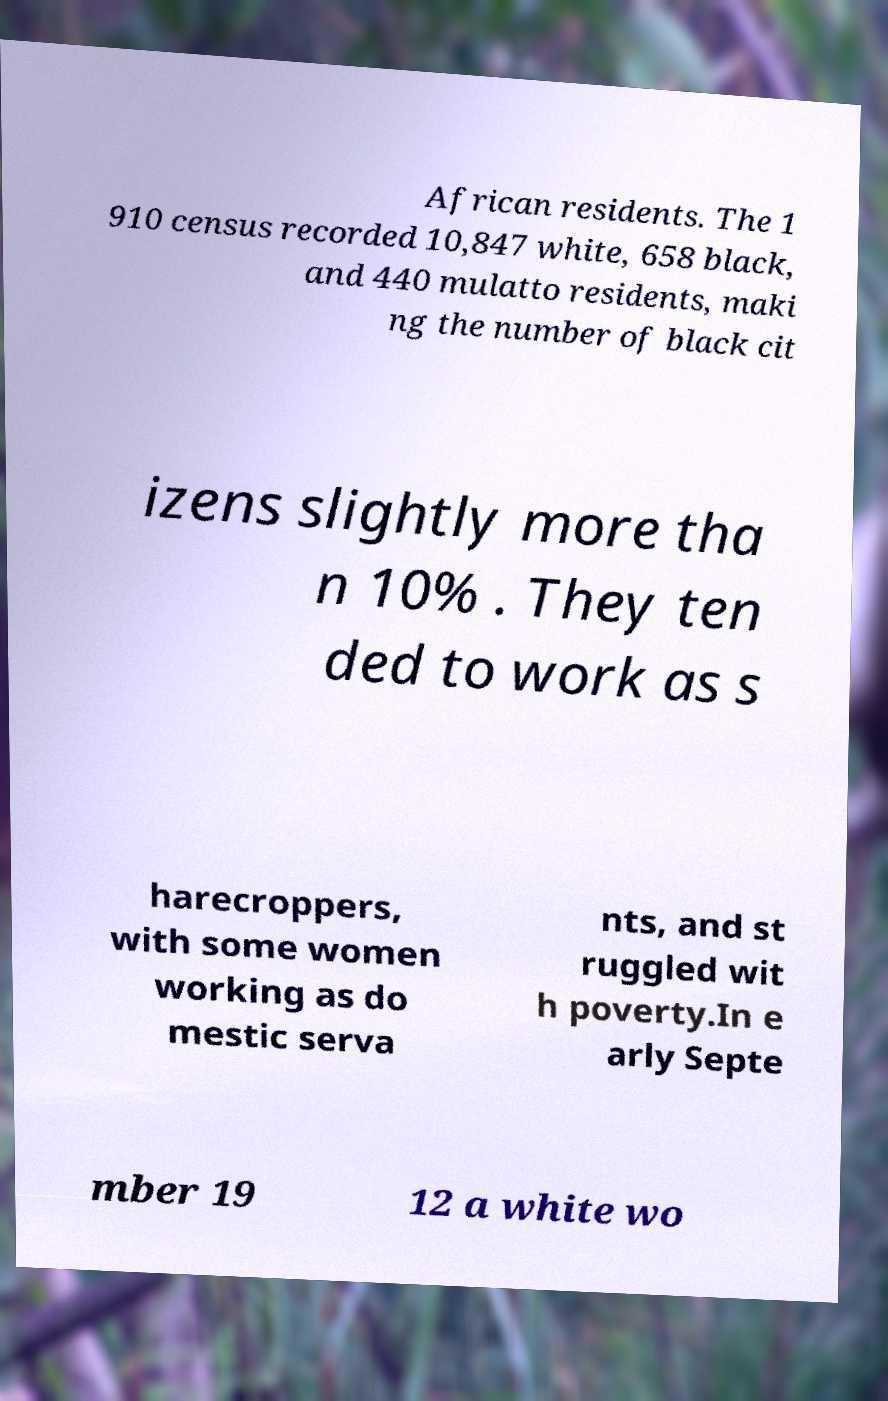Can you accurately transcribe the text from the provided image for me? African residents. The 1 910 census recorded 10,847 white, 658 black, and 440 mulatto residents, maki ng the number of black cit izens slightly more tha n 10% . They ten ded to work as s harecroppers, with some women working as do mestic serva nts, and st ruggled wit h poverty.In e arly Septe mber 19 12 a white wo 